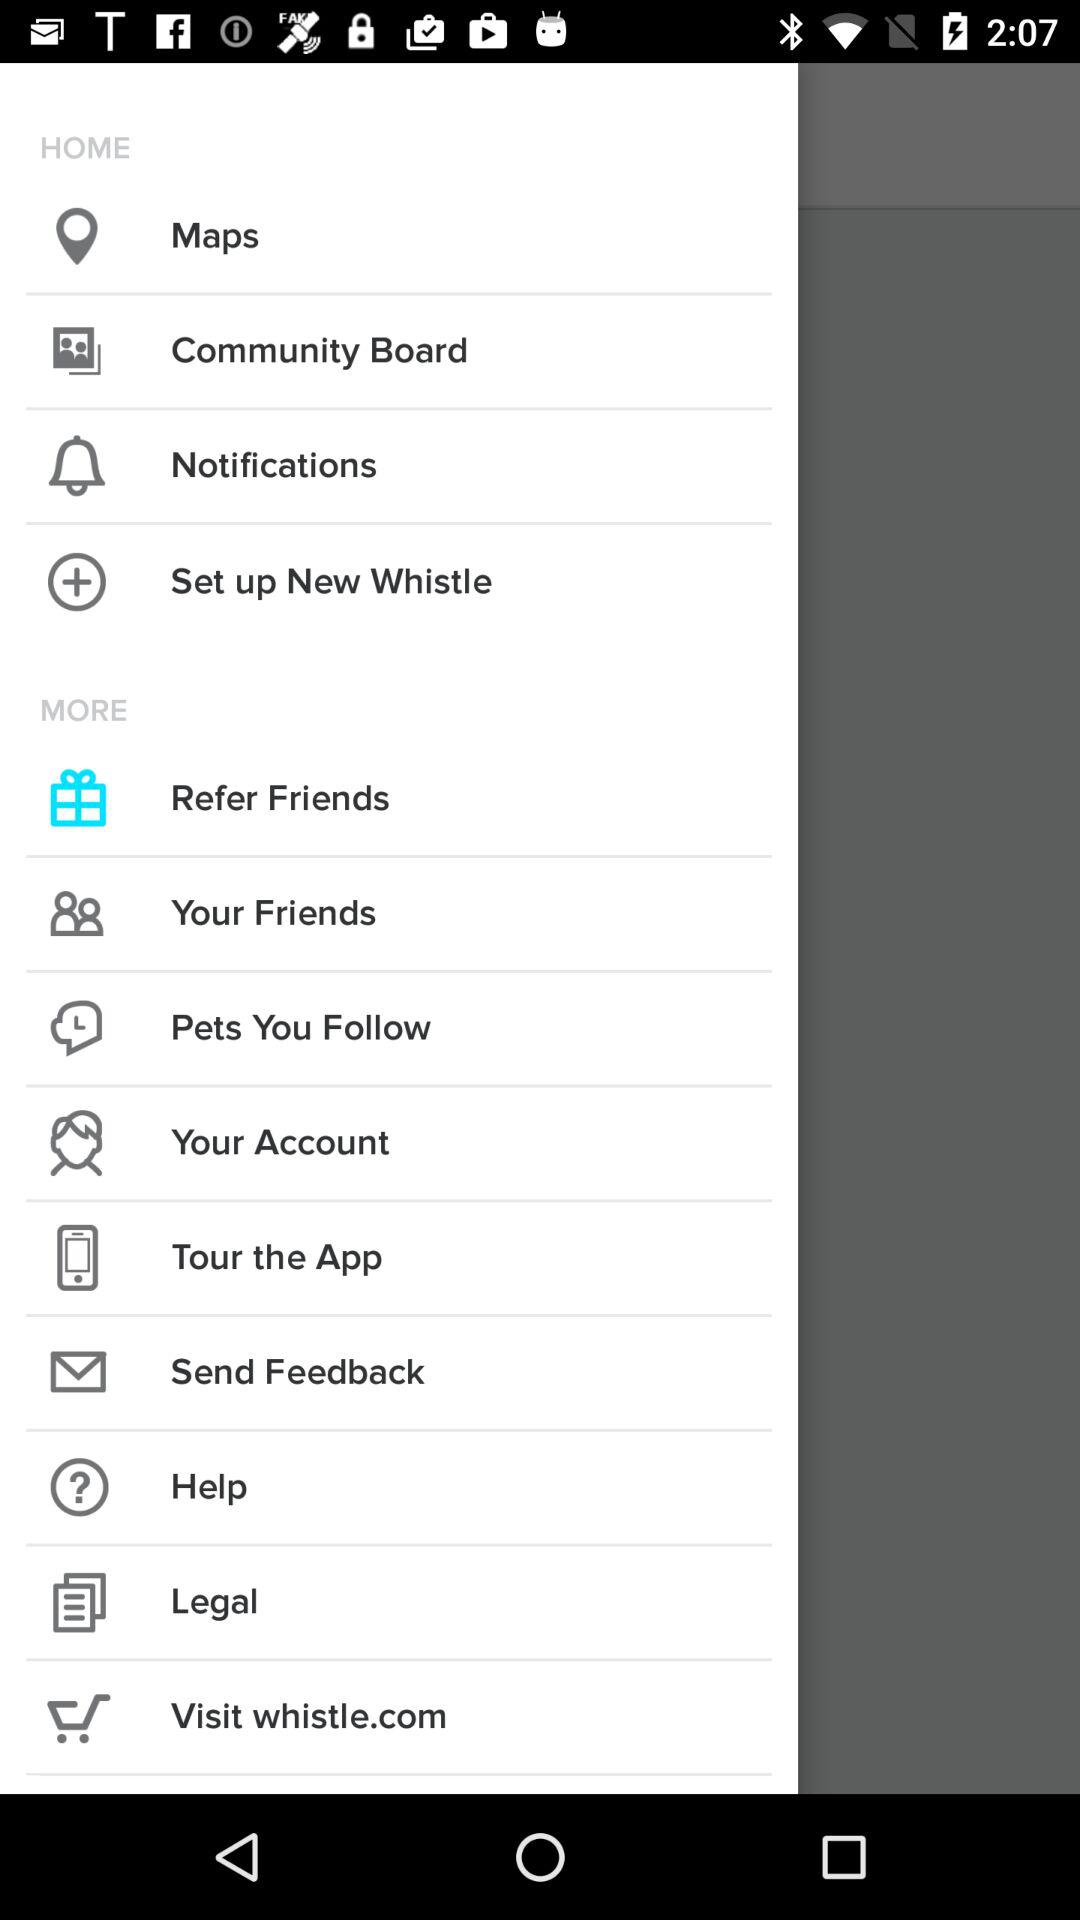What is the name of the application? The name of the application is "Whistle". 